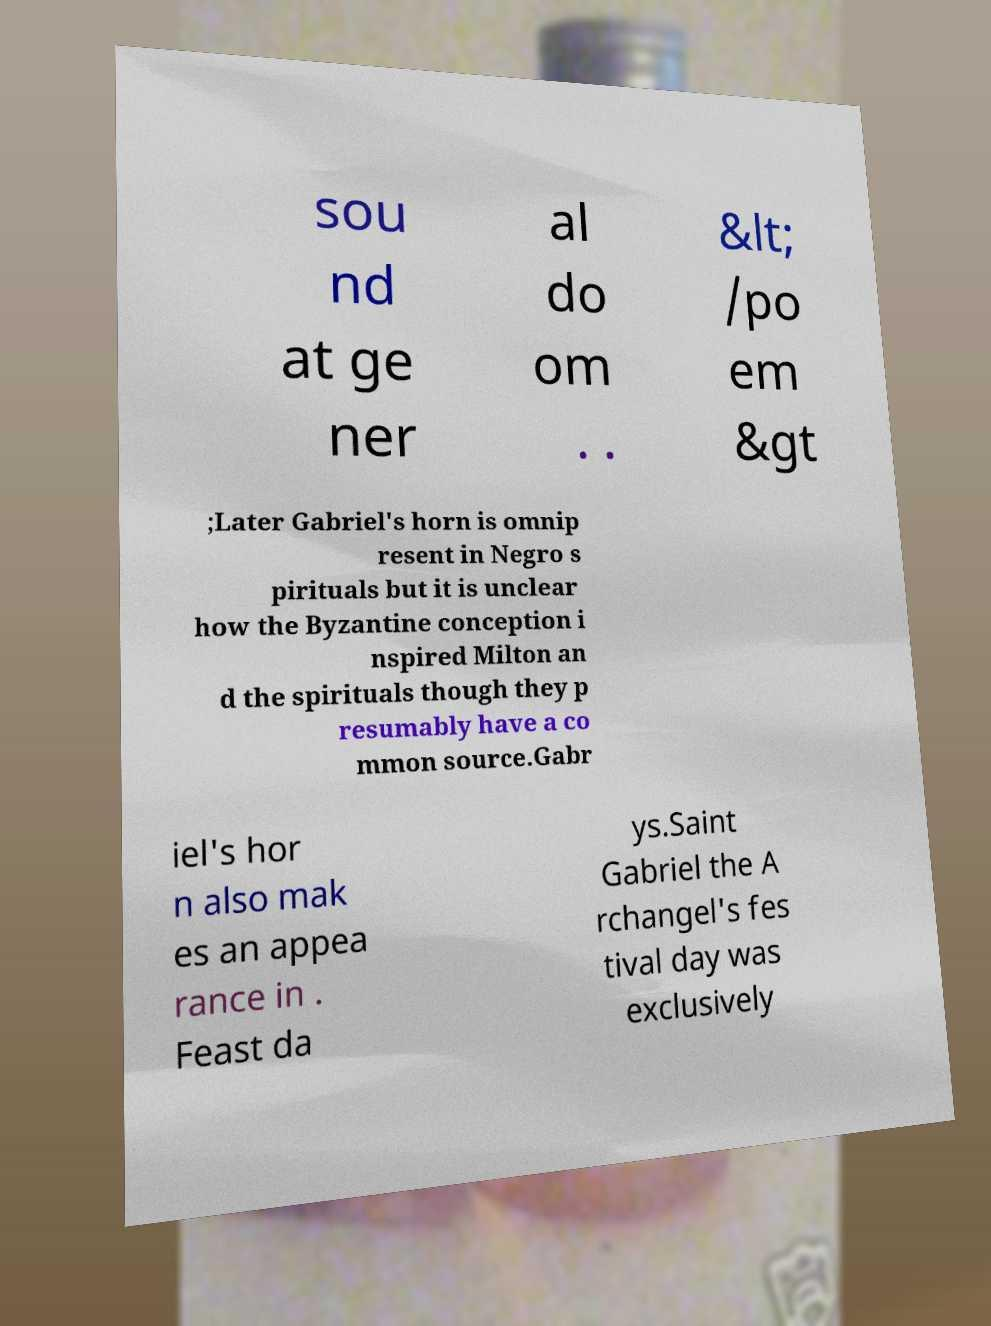Please read and relay the text visible in this image. What does it say? sou nd at ge ner al do om . . &lt; /po em &gt ;Later Gabriel's horn is omnip resent in Negro s pirituals but it is unclear how the Byzantine conception i nspired Milton an d the spirituals though they p resumably have a co mmon source.Gabr iel's hor n also mak es an appea rance in . Feast da ys.Saint Gabriel the A rchangel's fes tival day was exclusively 